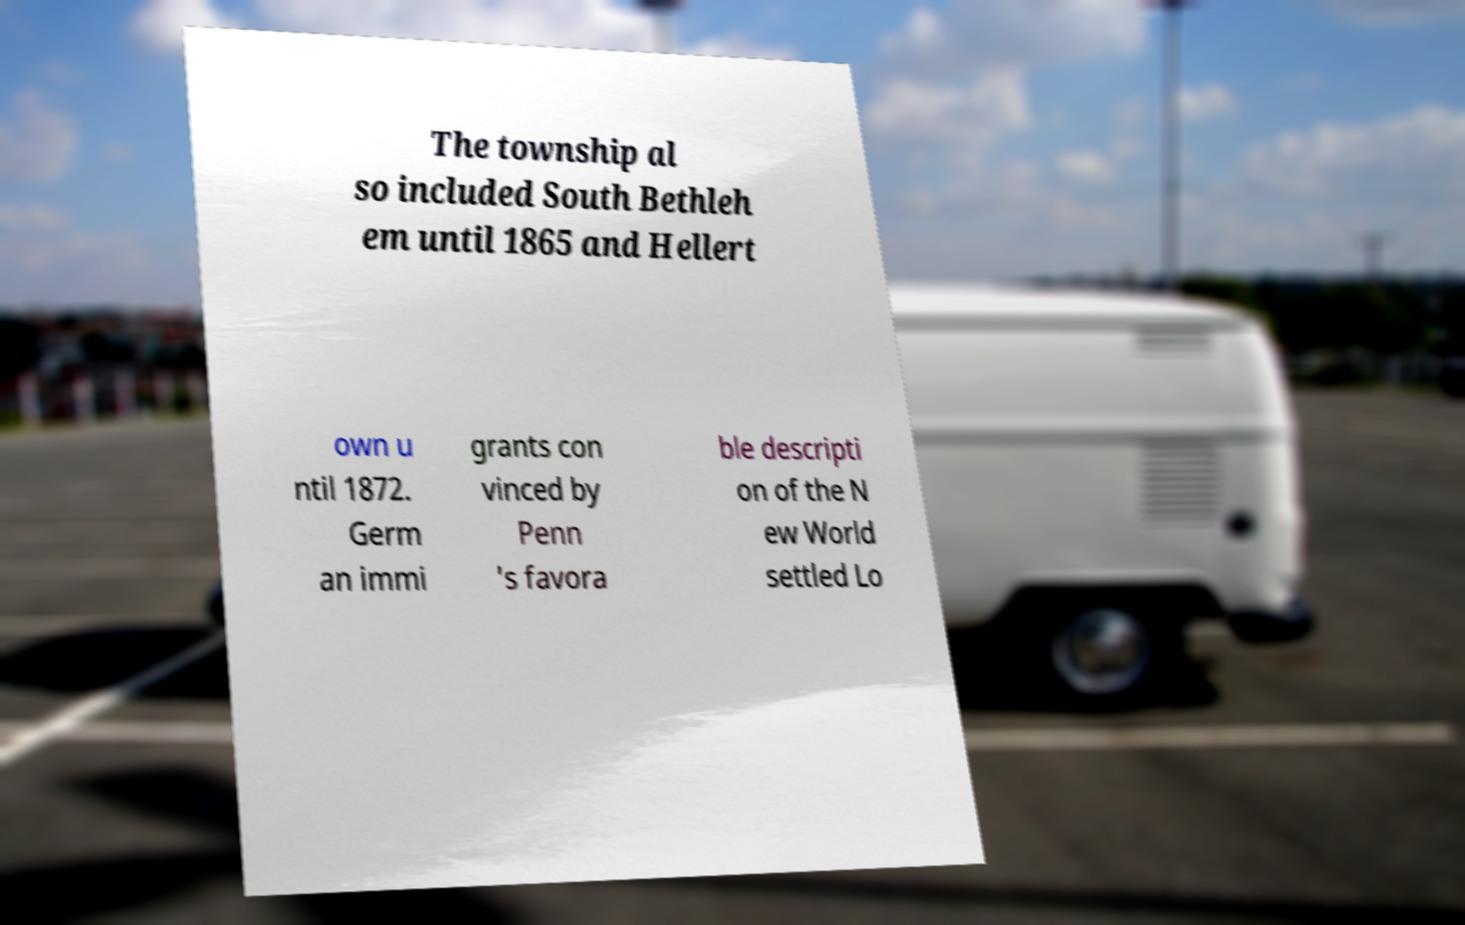Please read and relay the text visible in this image. What does it say? The township al so included South Bethleh em until 1865 and Hellert own u ntil 1872. Germ an immi grants con vinced by Penn 's favora ble descripti on of the N ew World settled Lo 